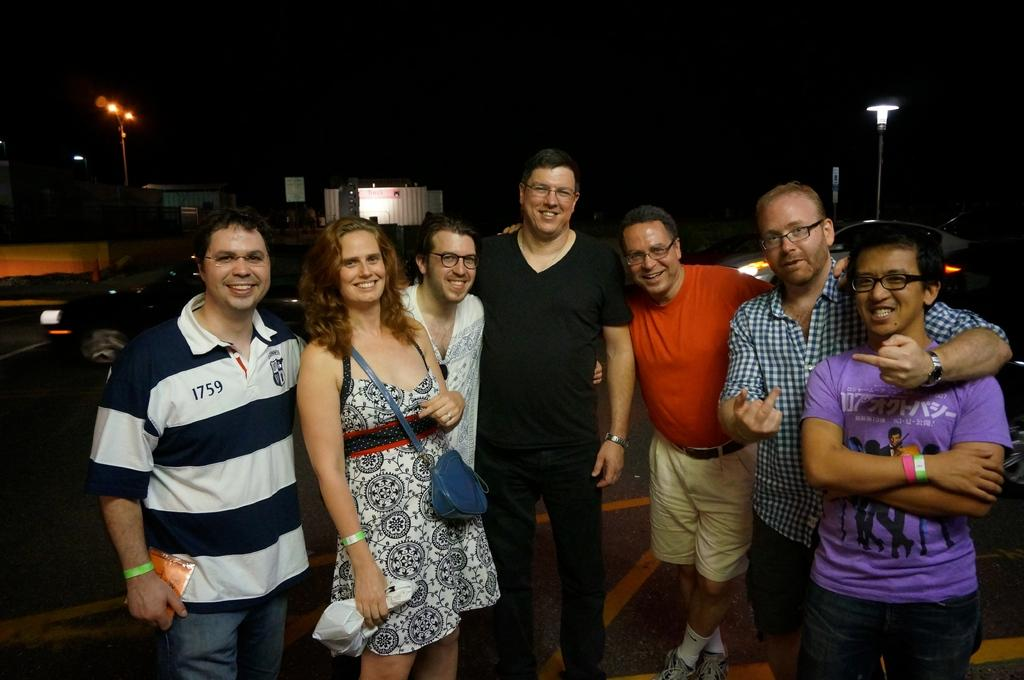What can be seen in the image? There are people standing in the image. What are the people wearing? The people are wearing colorful dresses. What can be seen in the background of the image? There are light poles, a vehicle, and other objects visible in the background. How would you describe the lighting in the image? The image appears to be dark. How many geese are present in the image? There are no geese present in the image. Can you describe the duck in the image? There is no duck present in the image. 